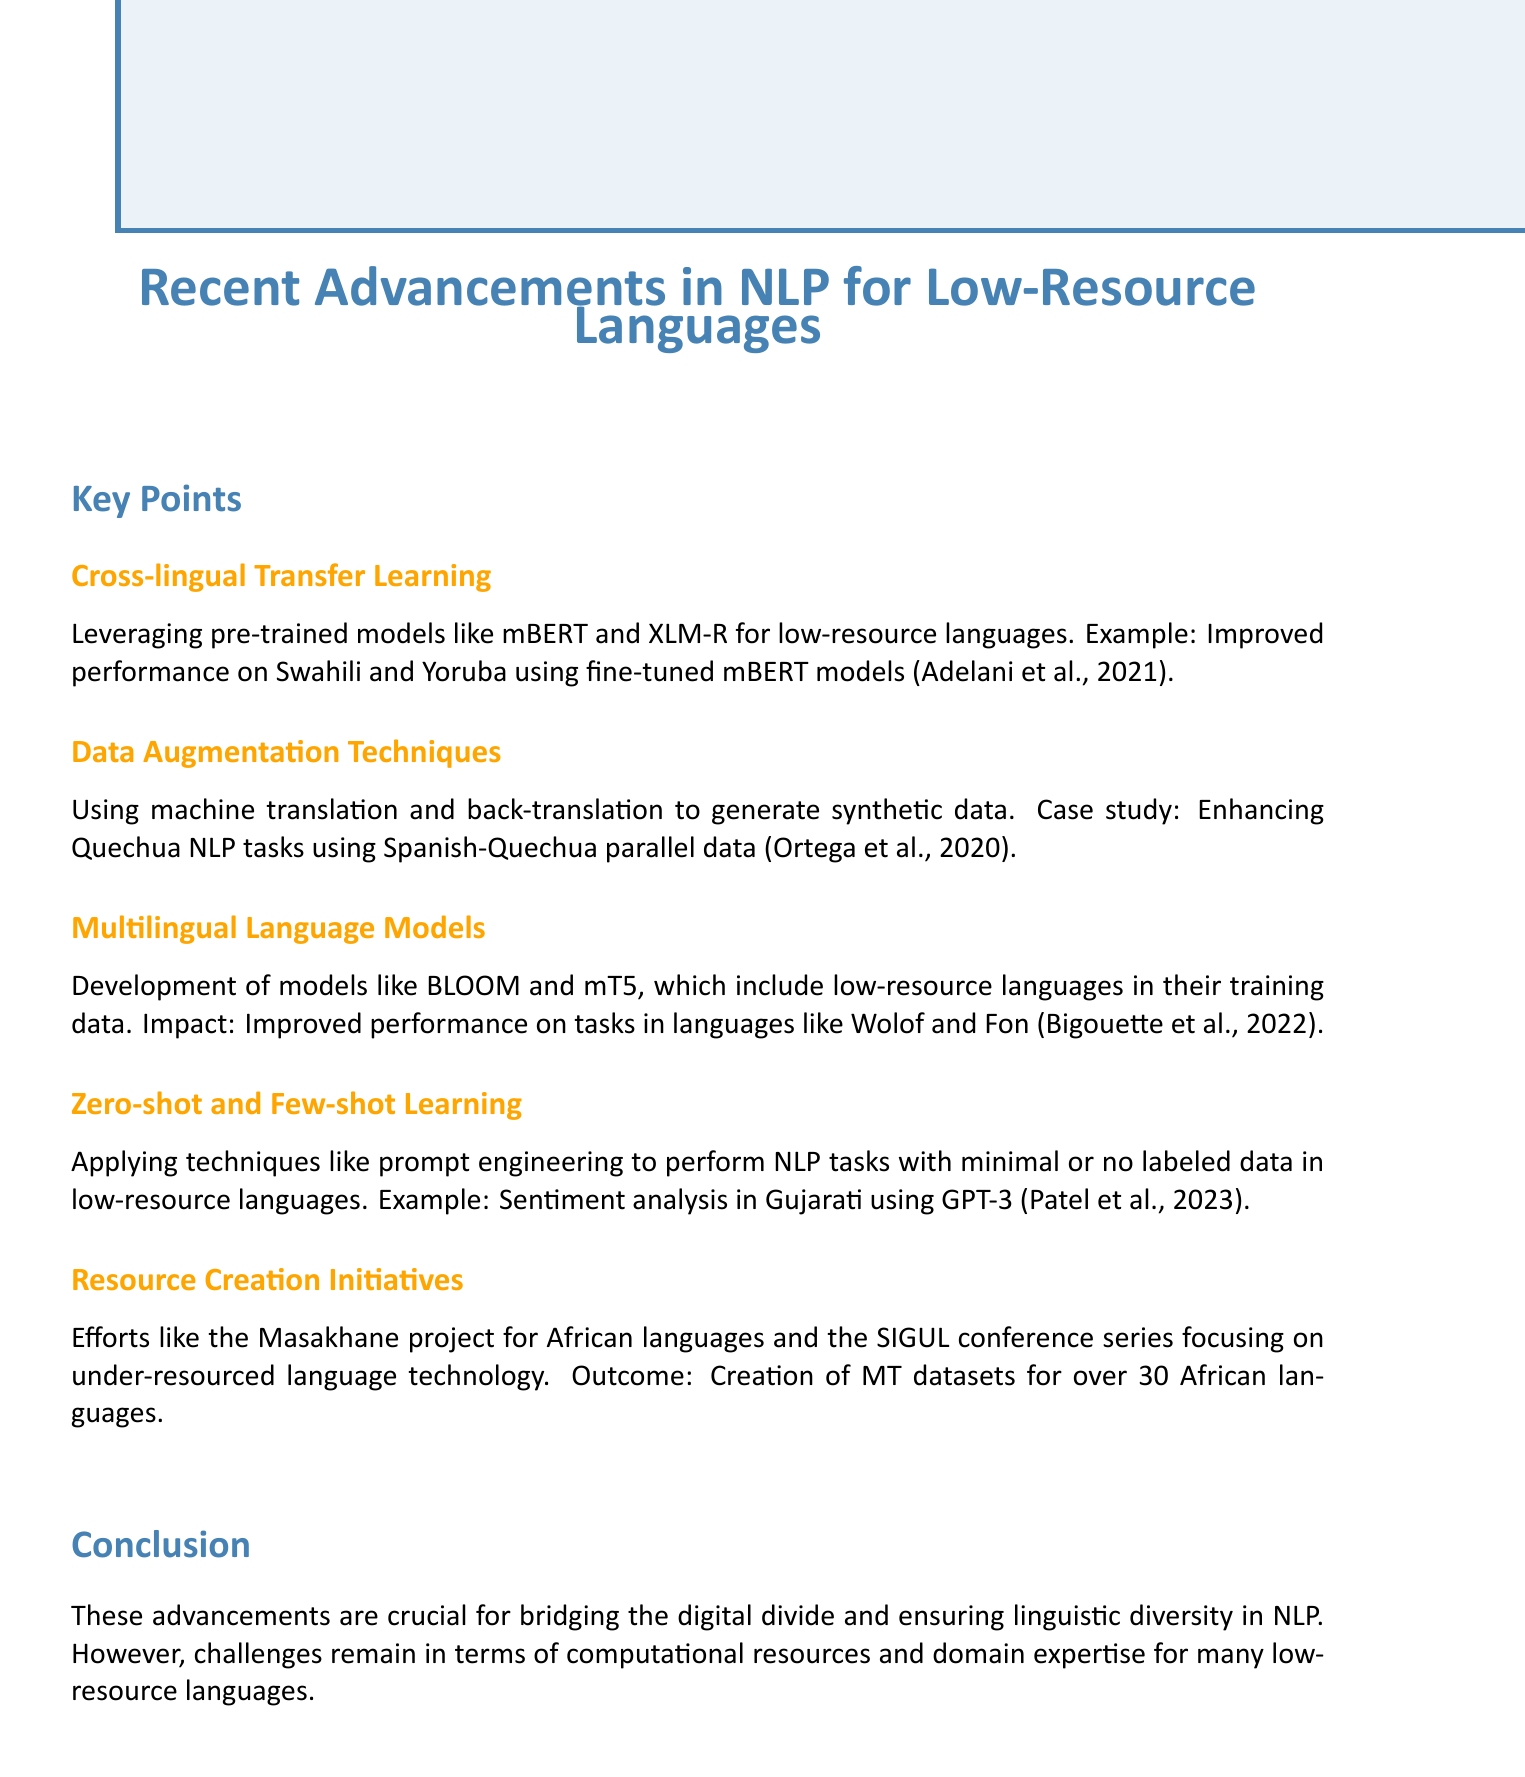What is the main topic of the document? The title of the document indicates its primary focus on advancements in natural language processing (NLP) specifically for low-resource languages.
Answer: Recent Advancements in NLP for Low-Resource Languages Which models are mentioned for cross-lingual transfer learning? The document refers to pre-trained models, specifically mentioning mBERT and XLM-R used in cross-lingual transfer learning.
Answer: mBERT and XLM-R What language pair was used in the data augmentation case study? The case study in the data augmentation section focuses on enhancing Quechua NLP tasks using data from another language, which is Spanish.
Answer: Spanish-Quechua How many African languages were referenced in the resource creation initiatives? The document states that the efforts in resource creation resulted in the creation of MT datasets for over 30 African languages.
Answer: 30 What technique is highlighted for zero-shot and few-shot learning? The section on zero-shot and few-shot learning discusses the application of prompt engineering as a technique.
Answer: Prompt engineering Which languages showed improved performance due to multilingual models? The impact of multilingual language models was specifically noted for enhancing performance in languages like Wolof and Fon.
Answer: Wolof and Fon What significant challenges remain according to the conclusion? The conclusion addresses specific challenges that are hindering advancements, particularly mentioning the need for computational resources and domain expertise.
Answer: Computational resources and domain expertise 